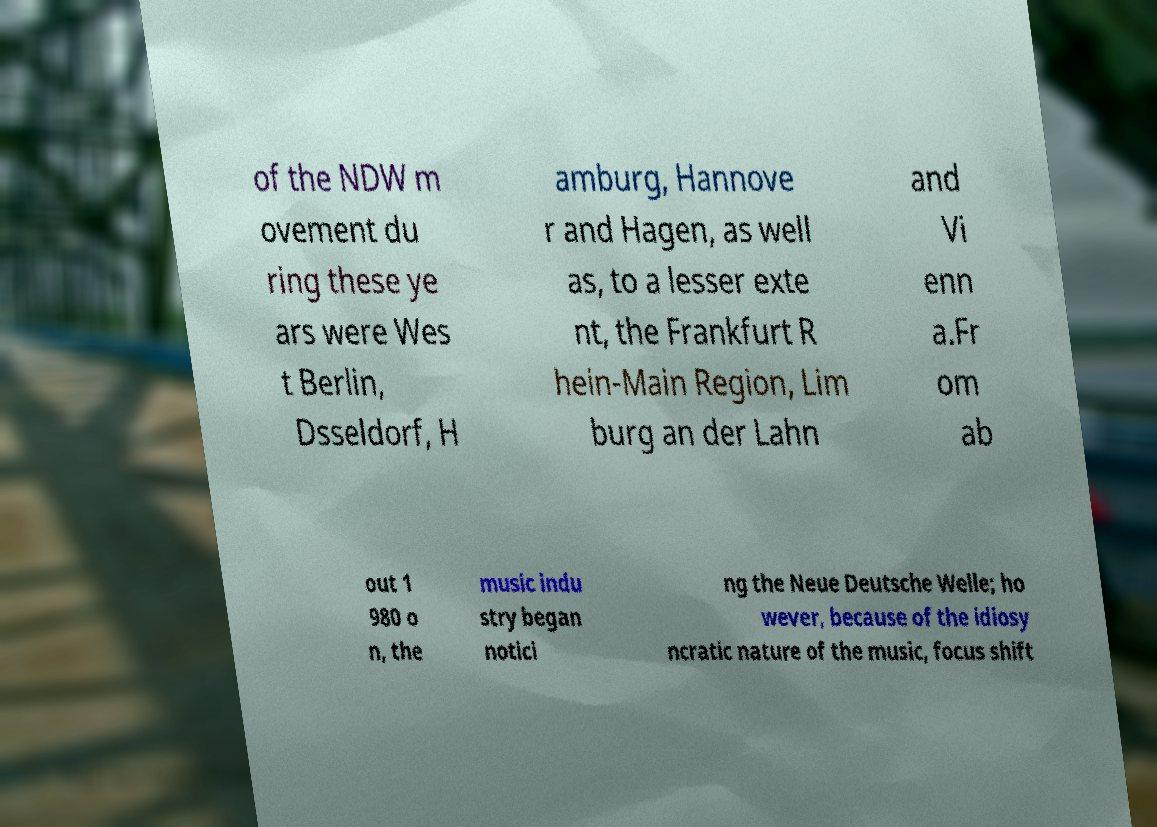What messages or text are displayed in this image? I need them in a readable, typed format. of the NDW m ovement du ring these ye ars were Wes t Berlin, Dsseldorf, H amburg, Hannove r and Hagen, as well as, to a lesser exte nt, the Frankfurt R hein-Main Region, Lim burg an der Lahn and Vi enn a.Fr om ab out 1 980 o n, the music indu stry began notici ng the Neue Deutsche Welle; ho wever, because of the idiosy ncratic nature of the music, focus shift 